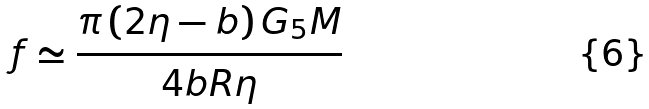<formula> <loc_0><loc_0><loc_500><loc_500>f \simeq \frac { \pi \left ( 2 \eta - b \right ) G _ { 5 } M } { 4 b R \eta }</formula> 